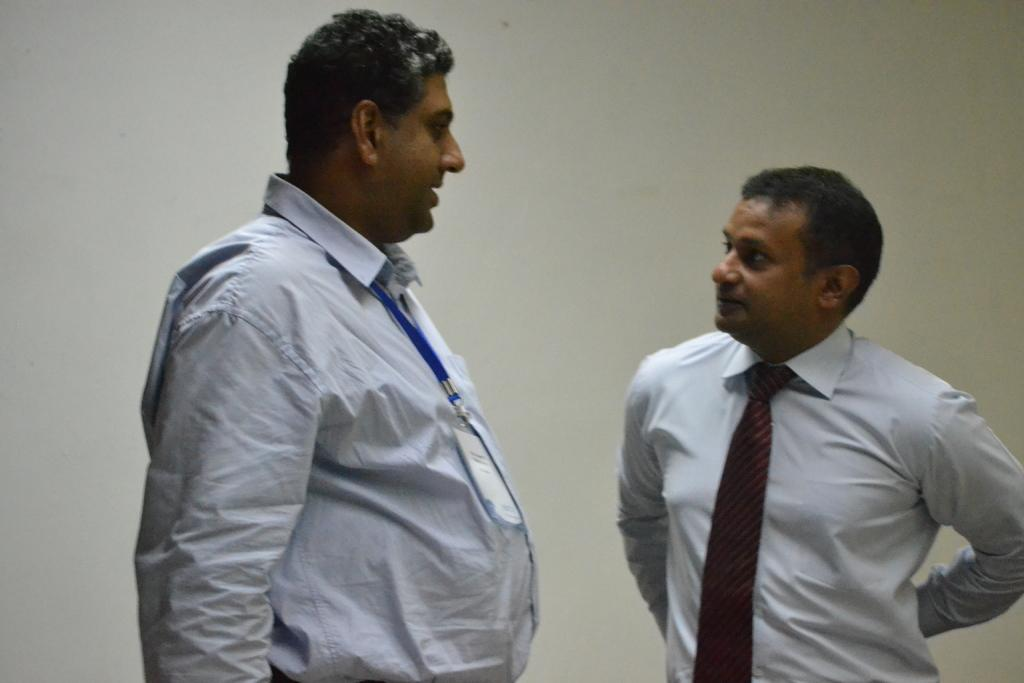How many men are in the image? There are two men standing in the image. What are the men wearing on their upper bodies? Both men are wearing white shirts and ties. Do the men have any identification visible in the image? Yes, both men have ID cards. What can be seen in the background of the image? There is a wall in the background of the image. What type of straw is growing on the grass in the image? There is no straw or grass present in the image; it features two men standing with ID cards. What is the cause of the loss experienced by the men in the image? There is no indication of loss or any emotional state in the image; it simply shows two men standing with ID cards. 